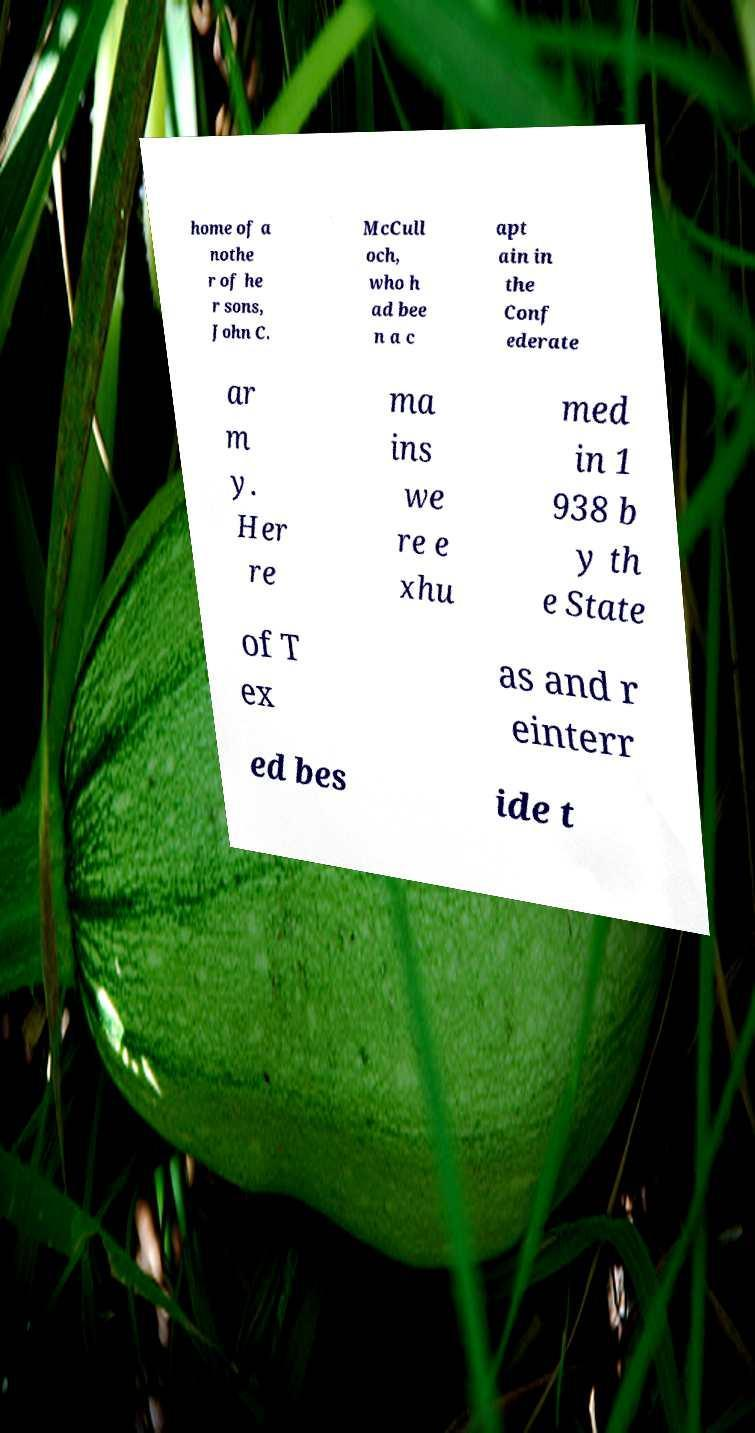Could you assist in decoding the text presented in this image and type it out clearly? home of a nothe r of he r sons, John C. McCull och, who h ad bee n a c apt ain in the Conf ederate ar m y. Her re ma ins we re e xhu med in 1 938 b y th e State of T ex as and r einterr ed bes ide t 